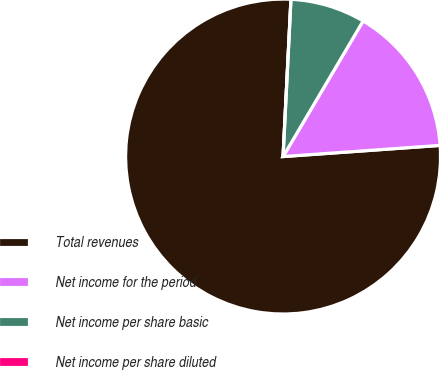Convert chart to OTSL. <chart><loc_0><loc_0><loc_500><loc_500><pie_chart><fcel>Total revenues<fcel>Net income for the period<fcel>Net income per share basic<fcel>Net income per share diluted<nl><fcel>76.92%<fcel>15.38%<fcel>7.69%<fcel>0.0%<nl></chart> 